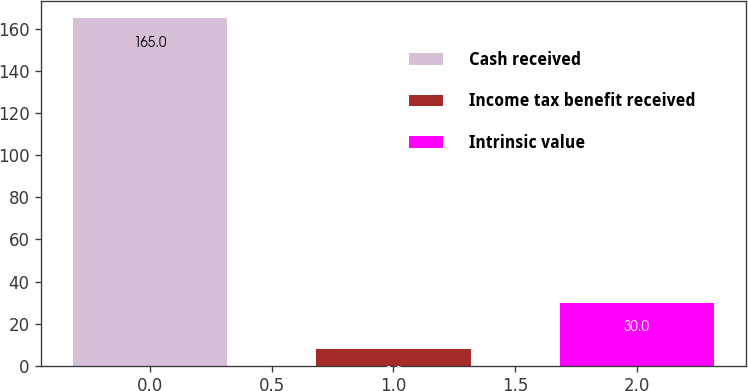<chart> <loc_0><loc_0><loc_500><loc_500><bar_chart><fcel>Cash received<fcel>Income tax benefit received<fcel>Intrinsic value<nl><fcel>165<fcel>8<fcel>30<nl></chart> 